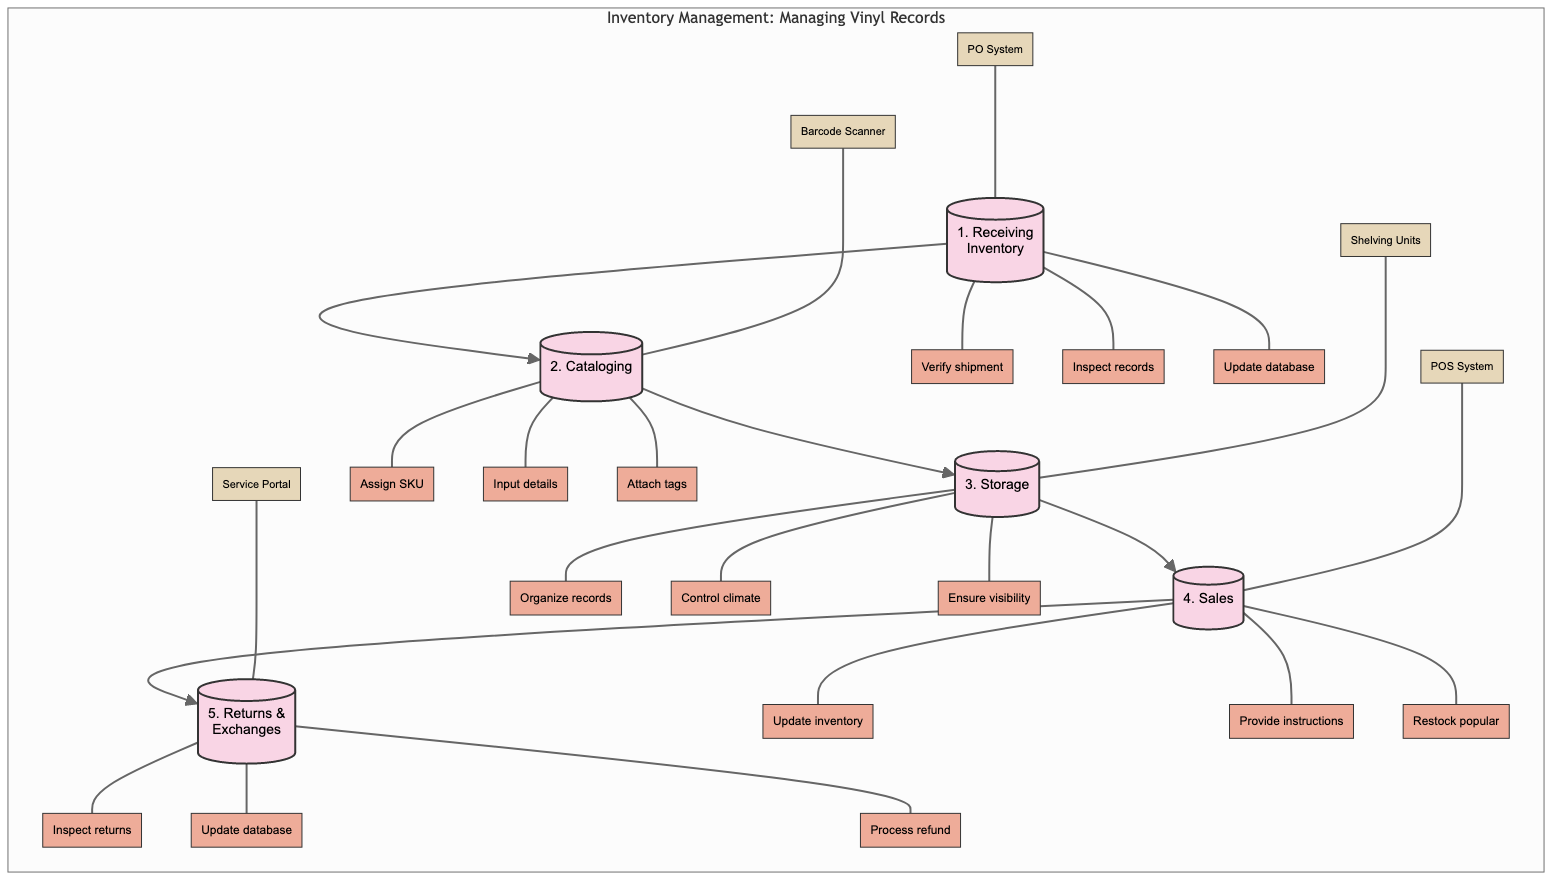What is the first step in the inventory management process? The diagram shows that the first step in the inventory management process is "Receiving Inventory."
Answer: Receiving Inventory How many actions are listed under the Cataloging step? In the diagram, there are three actions listed under the Cataloging step: "Assign unique SKU to each record," "Input artist, album, genre, and release year," and "Attach price tags and security tags."
Answer: Three What tool is associated with the Sales step? The diagram indicates that the tool associated with the Sales step is the "Point of Sale System."
Answer: Point of Sale System What step follows Cataloging in the process? The diagram clearly shows that the step that follows Cataloging is "Storage."
Answer: Storage Which action is performed in the Returns and Exchanges step? The diagram lists "Inspect returned records for damage" as one of the actions performed in the Returns and Exchanges step.
Answer: Inspect returned records for damage Which tool is used when receiving inventory? According to the diagram, the tool used when receiving inventory is the "Purchase Order System."
Answer: Purchase Order System How many steps are in the entire inventory management process? The diagram outlines a total of five steps in the inventory management process: Receiving Inventory, Cataloging, Storage, Sales, and Returns & Exchanges.
Answer: Five What action occurs immediately after inspecting vinyl records for damage? After the action of inspecting vinyl records for damage, the next action is to "Update inventory database with new arrivals."
Answer: Update inventory database with new arrivals Which step includes restocking popular records? The step that includes the action of restocking popular records based on sales data is "Sales."
Answer: Sales 